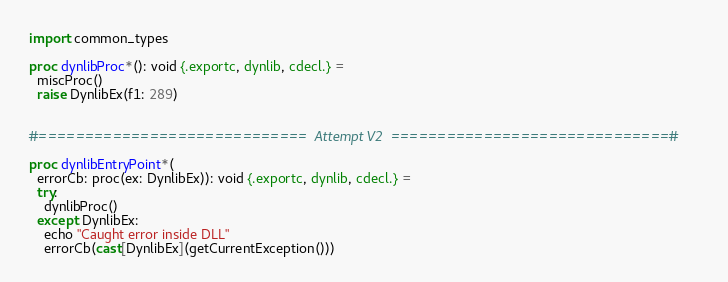Convert code to text. <code><loc_0><loc_0><loc_500><loc_500><_Nim_>import common_types

proc dynlibProc*(): void {.exportc, dynlib, cdecl.} =
  miscProc()
  raise DynlibEx(f1: 289)


#=============================  Attempt V2  ==============================#

proc dynlibEntryPoint*(
  errorCb: proc(ex: DynlibEx)): void {.exportc, dynlib, cdecl.} =
  try:
    dynlibProc()
  except DynlibEx:
    echo "Caught error inside DLL"
    errorCb(cast[DynlibEx](getCurrentException()))
</code> 